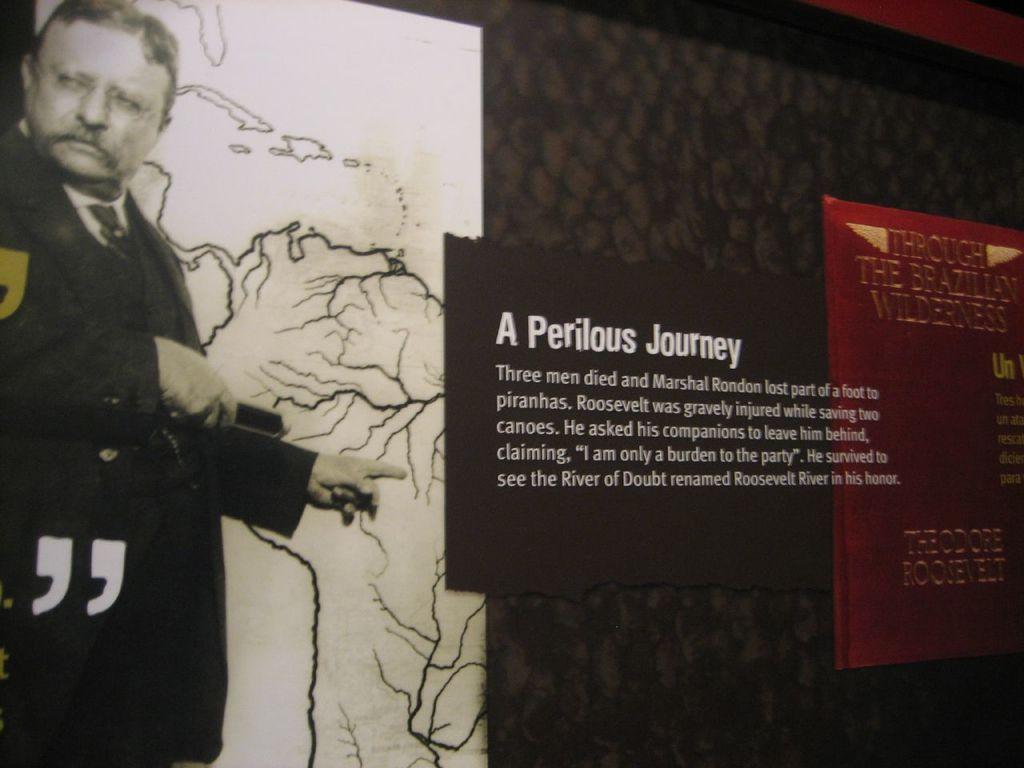How did marshal rondon lose part of his foot?
Your answer should be very brief. Piranhas. What former president was injured saving two canoes?
Your answer should be compact. Roosevelt. 